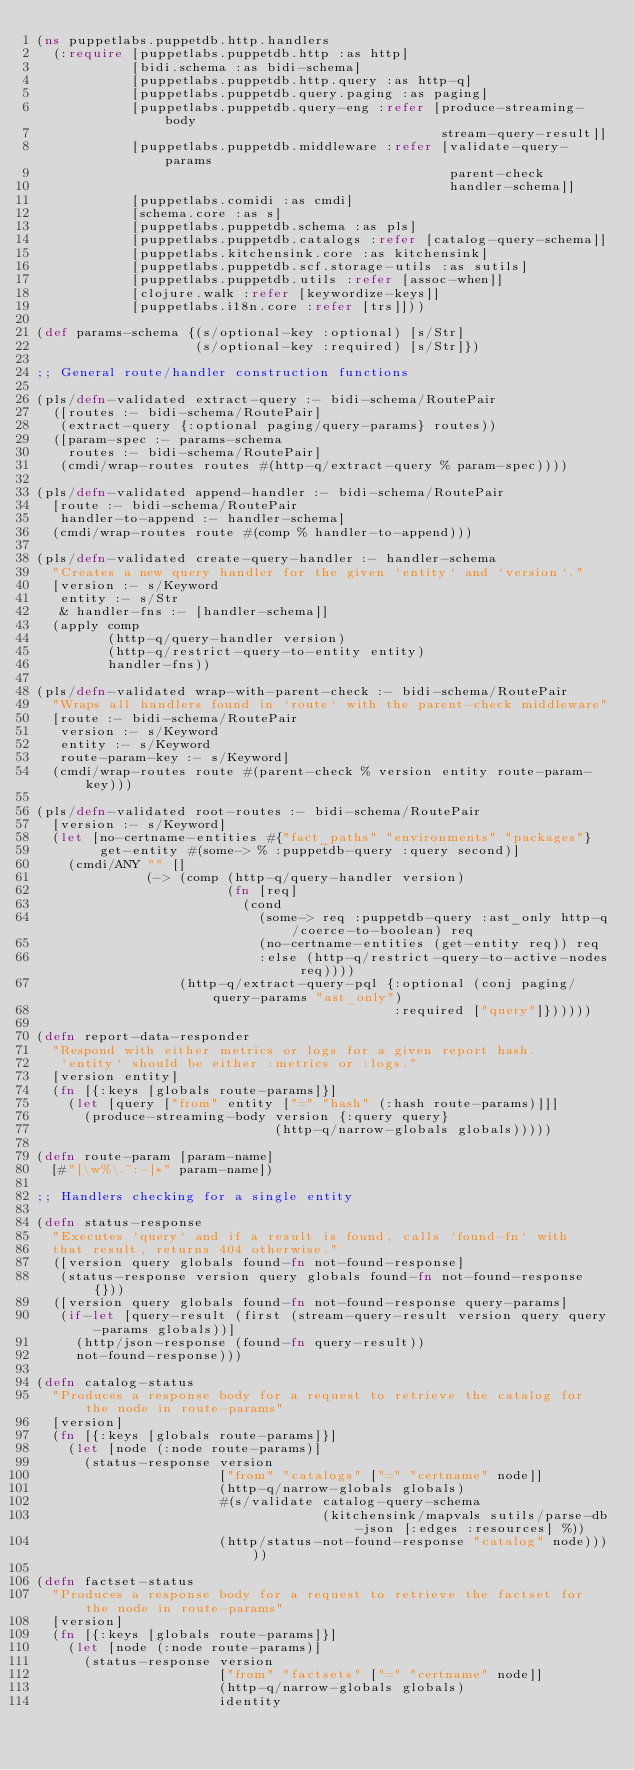Convert code to text. <code><loc_0><loc_0><loc_500><loc_500><_Clojure_>(ns puppetlabs.puppetdb.http.handlers
  (:require [puppetlabs.puppetdb.http :as http]
            [bidi.schema :as bidi-schema]
            [puppetlabs.puppetdb.http.query :as http-q]
            [puppetlabs.puppetdb.query.paging :as paging]
            [puppetlabs.puppetdb.query-eng :refer [produce-streaming-body
                                                   stream-query-result]]
            [puppetlabs.puppetdb.middleware :refer [validate-query-params
                                                    parent-check
                                                    handler-schema]]
            [puppetlabs.comidi :as cmdi]
            [schema.core :as s]
            [puppetlabs.puppetdb.schema :as pls]
            [puppetlabs.puppetdb.catalogs :refer [catalog-query-schema]]
            [puppetlabs.kitchensink.core :as kitchensink]
            [puppetlabs.puppetdb.scf.storage-utils :as sutils]
            [puppetlabs.puppetdb.utils :refer [assoc-when]]
            [clojure.walk :refer [keywordize-keys]]
            [puppetlabs.i18n.core :refer [trs]]))

(def params-schema {(s/optional-key :optional) [s/Str]
                    (s/optional-key :required) [s/Str]})

;; General route/handler construction functions

(pls/defn-validated extract-query :- bidi-schema/RoutePair
  ([routes :- bidi-schema/RoutePair]
   (extract-query {:optional paging/query-params} routes))
  ([param-spec :- params-schema
    routes :- bidi-schema/RoutePair]
   (cmdi/wrap-routes routes #(http-q/extract-query % param-spec))))

(pls/defn-validated append-handler :- bidi-schema/RoutePair
  [route :- bidi-schema/RoutePair
   handler-to-append :- handler-schema]
  (cmdi/wrap-routes route #(comp % handler-to-append)))

(pls/defn-validated create-query-handler :- handler-schema
  "Creates a new query handler for the given `entity` and `version`."
  [version :- s/Keyword
   entity :- s/Str
   & handler-fns :- [handler-schema]]
  (apply comp
         (http-q/query-handler version)
         (http-q/restrict-query-to-entity entity)
         handler-fns))

(pls/defn-validated wrap-with-parent-check :- bidi-schema/RoutePair
  "Wraps all handlers found in `route` with the parent-check middleware"
  [route :- bidi-schema/RoutePair
   version :- s/Keyword
   entity :- s/Keyword
   route-param-key :- s/Keyword]
  (cmdi/wrap-routes route #(parent-check % version entity route-param-key)))

(pls/defn-validated root-routes :- bidi-schema/RoutePair
  [version :- s/Keyword]
  (let [no-certname-entities #{"fact_paths" "environments" "packages"}
        get-entity #(some-> % :puppetdb-query :query second)]
    (cmdi/ANY "" []
              (-> (comp (http-q/query-handler version)
                        (fn [req]
                          (cond
                            (some-> req :puppetdb-query :ast_only http-q/coerce-to-boolean) req
                            (no-certname-entities (get-entity req)) req
                            :else (http-q/restrict-query-to-active-nodes req))))
                  (http-q/extract-query-pql {:optional (conj paging/query-params "ast_only")
                                             :required ["query"]})))))

(defn report-data-responder
  "Respond with either metrics or logs for a given report hash.
   `entity` should be either :metrics or :logs."
  [version entity]
  (fn [{:keys [globals route-params]}]
    (let [query ["from" entity ["=" "hash" (:hash route-params)]]]
      (produce-streaming-body version {:query query}
                              (http-q/narrow-globals globals)))))

(defn route-param [param-name]
  [#"[\w%\.~:-]*" param-name])

;; Handlers checking for a single entity

(defn status-response
  "Executes `query` and if a result is found, calls `found-fn` with
  that result, returns 404 otherwise."
  ([version query globals found-fn not-found-response]
   (status-response version query globals found-fn not-found-response {}))
  ([version query globals found-fn not-found-response query-params]
   (if-let [query-result (first (stream-query-result version query query-params globals))]
     (http/json-response (found-fn query-result))
     not-found-response)))

(defn catalog-status
  "Produces a response body for a request to retrieve the catalog for the node in route-params"
  [version]
  (fn [{:keys [globals route-params]}]
    (let [node (:node route-params)]
      (status-response version
                       ["from" "catalogs" ["=" "certname" node]]
                       (http-q/narrow-globals globals)
                       #(s/validate catalog-query-schema
                                    (kitchensink/mapvals sutils/parse-db-json [:edges :resources] %))
                       (http/status-not-found-response "catalog" node)))))

(defn factset-status
  "Produces a response body for a request to retrieve the factset for the node in route-params"
  [version]
  (fn [{:keys [globals route-params]}]
    (let [node (:node route-params)]
      (status-response version
                       ["from" "factsets" ["=" "certname" node]]
                       (http-q/narrow-globals globals)
                       identity</code> 